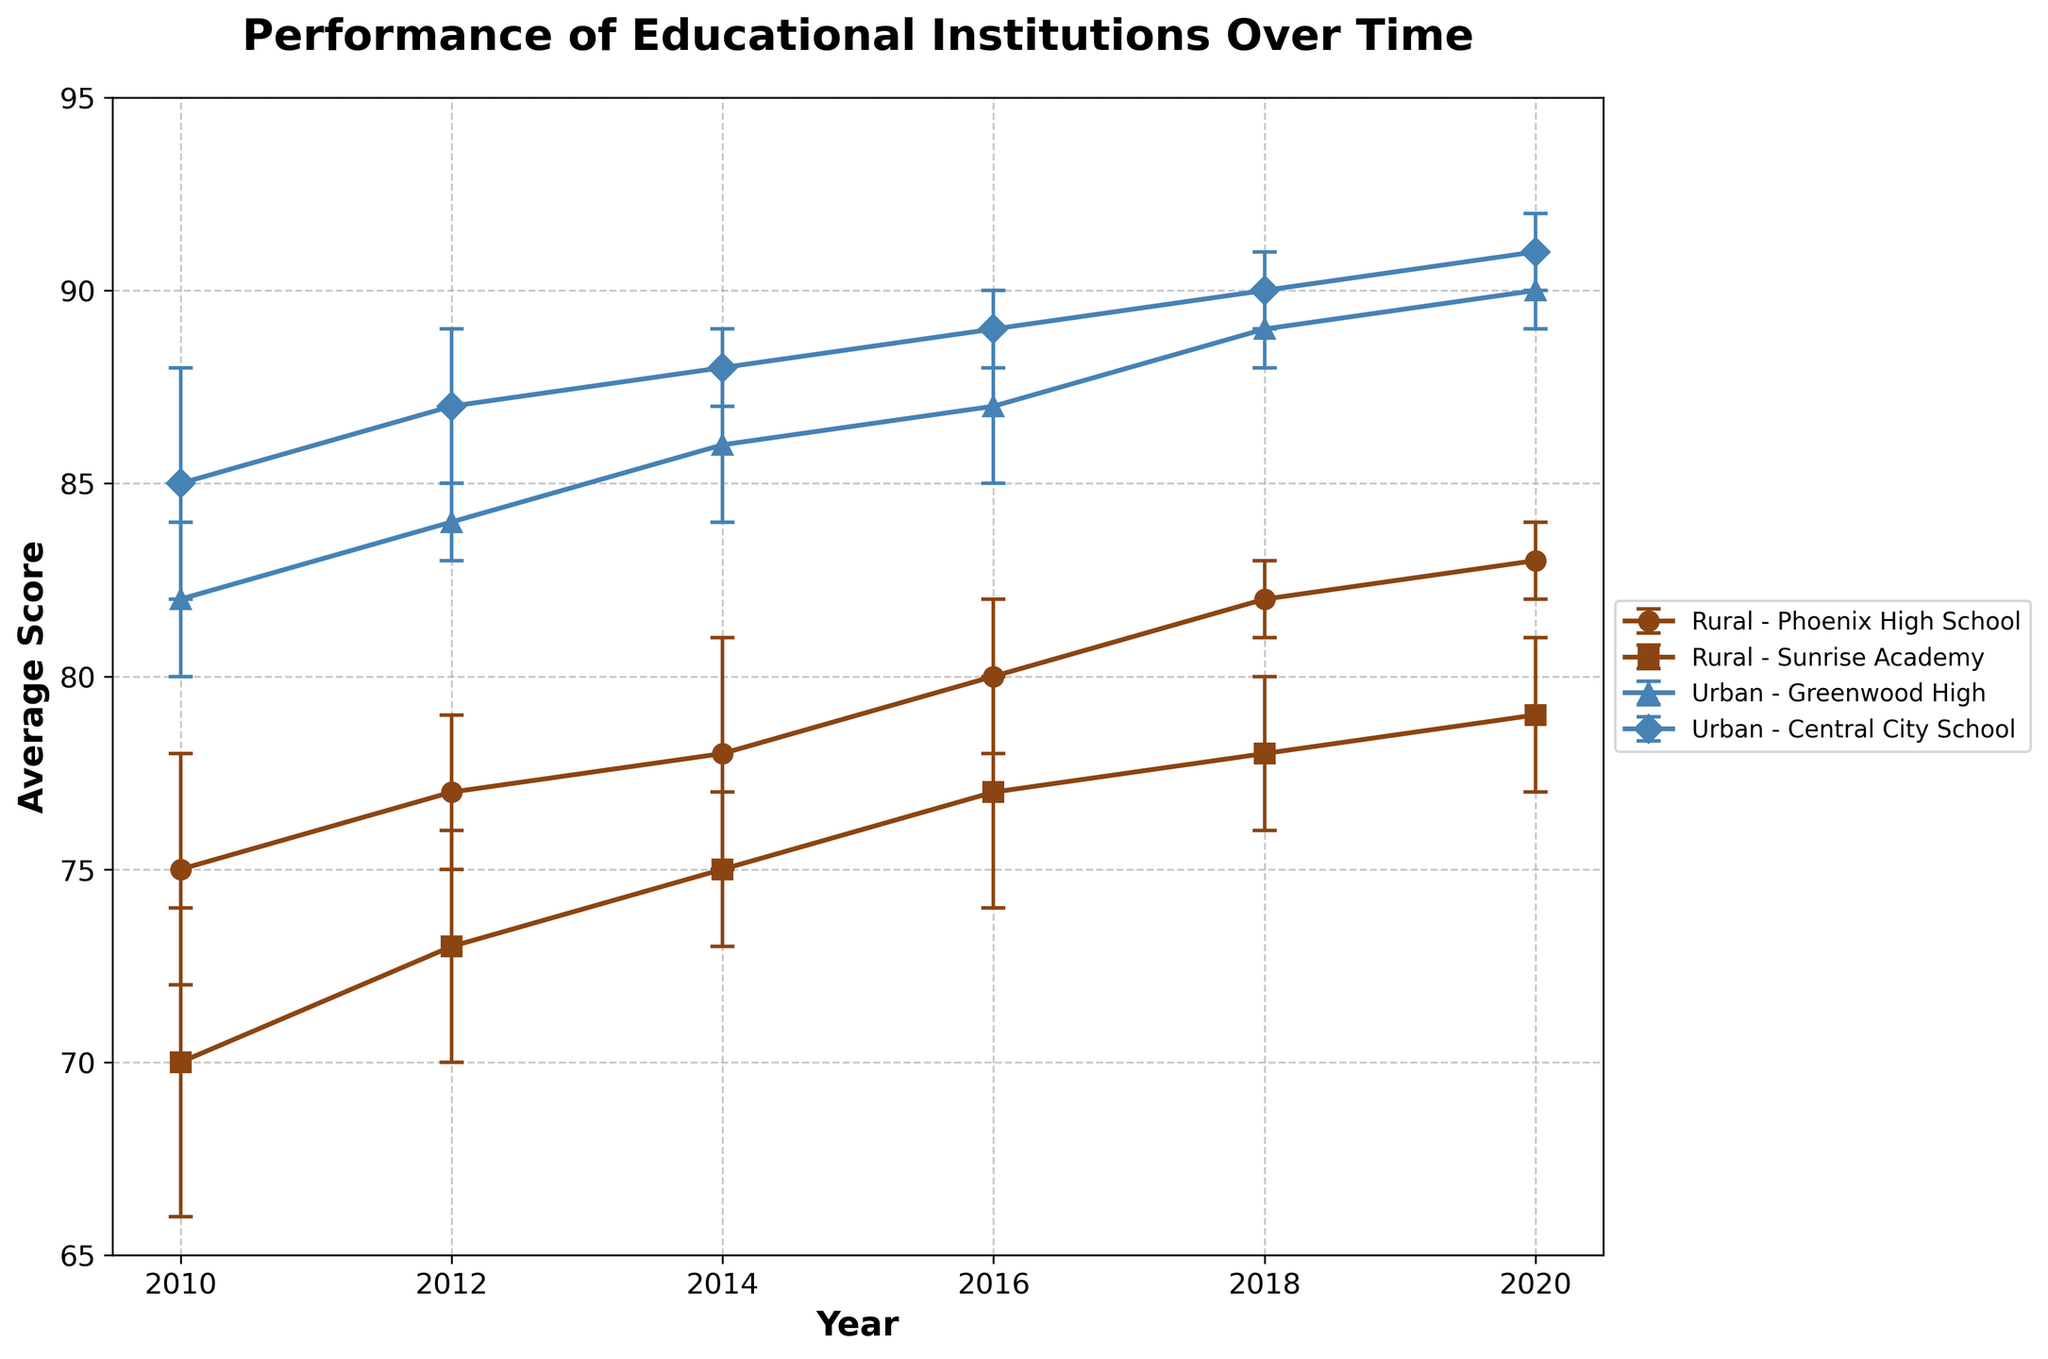What is the title of the figure? The title of the figure is usually displayed at the top of the plot and helps provide a brief description of what the figure is showing.
Answer: Performance of Educational Institutions Over Time Which school had the highest average score in 2020? Look at the year 2020 and identify the school with the highest average score in both rural and urban areas.
Answer: Central City School What is the average score difference between Phoenix High School in 2010 and 2020? Find the average scores of Phoenix High School in 2010 and 2020 from the plot, then calculate the difference by subtracting the 2010 score from the 2020 score.
Answer: 8 How do the scores of Sunrise Academy change over the years? Trace the line representing Sunrise Academy from 2010 to 2020, observing the trend whether it increases, decreases, or fluctuates.
Answer: Increase Which school in the urban area shows the least improvement from 2010 to 2020? Find the average scores of both urban schools in 2010 and 2020, then calculate the difference for each and identify the one with the smallest difference.
Answer: Greenwood High Between rural and urban areas, which one shows generally higher student performance? Compare the trends of the lines representing rural schools with those of urban schools over the years and determine which group of lines generally lies higher on the plot.
Answer: Urban What is the error range for Sunrise Academy in 2016? Locate the data point for Sunrise Academy in 2016 and check the error bars, which display the range of possible values around the average score.
Answer: 74 to 80 By how much did the average score of Central City School increase between 2012 and 2018? Subtract the average score of Central City School in 2012 from its average score in 2018 to find the increase.
Answer: 3 Which rural school consistently performs better over the years? Compare the lines representing Phoenix High School and Sunrise Academy over the years to see which one generally has higher average scores.
Answer: Phoenix High School Is there a significant difference in average scores between rural and urban schools in 2018? Compare the average scores and their error bars for both rural and urban schools in 2018 to see if there is a noticeable difference.
Answer: Yes 